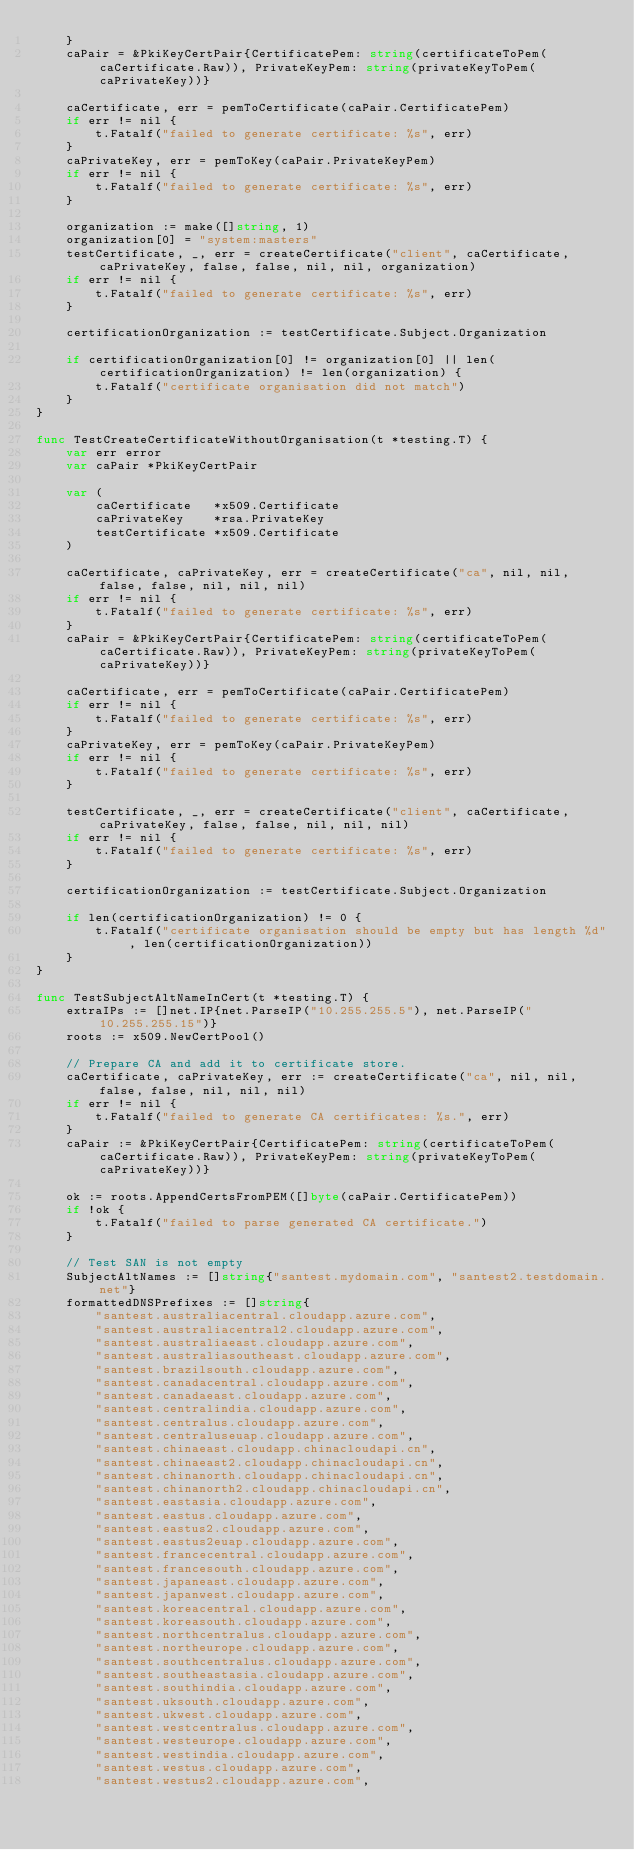Convert code to text. <code><loc_0><loc_0><loc_500><loc_500><_Go_>	}
	caPair = &PkiKeyCertPair{CertificatePem: string(certificateToPem(caCertificate.Raw)), PrivateKeyPem: string(privateKeyToPem(caPrivateKey))}

	caCertificate, err = pemToCertificate(caPair.CertificatePem)
	if err != nil {
		t.Fatalf("failed to generate certificate: %s", err)
	}
	caPrivateKey, err = pemToKey(caPair.PrivateKeyPem)
	if err != nil {
		t.Fatalf("failed to generate certificate: %s", err)
	}

	organization := make([]string, 1)
	organization[0] = "system:masters"
	testCertificate, _, err = createCertificate("client", caCertificate, caPrivateKey, false, false, nil, nil, organization)
	if err != nil {
		t.Fatalf("failed to generate certificate: %s", err)
	}

	certificationOrganization := testCertificate.Subject.Organization

	if certificationOrganization[0] != organization[0] || len(certificationOrganization) != len(organization) {
		t.Fatalf("certificate organisation did not match")
	}
}

func TestCreateCertificateWithoutOrganisation(t *testing.T) {
	var err error
	var caPair *PkiKeyCertPair

	var (
		caCertificate   *x509.Certificate
		caPrivateKey    *rsa.PrivateKey
		testCertificate *x509.Certificate
	)

	caCertificate, caPrivateKey, err = createCertificate("ca", nil, nil, false, false, nil, nil, nil)
	if err != nil {
		t.Fatalf("failed to generate certificate: %s", err)
	}
	caPair = &PkiKeyCertPair{CertificatePem: string(certificateToPem(caCertificate.Raw)), PrivateKeyPem: string(privateKeyToPem(caPrivateKey))}

	caCertificate, err = pemToCertificate(caPair.CertificatePem)
	if err != nil {
		t.Fatalf("failed to generate certificate: %s", err)
	}
	caPrivateKey, err = pemToKey(caPair.PrivateKeyPem)
	if err != nil {
		t.Fatalf("failed to generate certificate: %s", err)
	}

	testCertificate, _, err = createCertificate("client", caCertificate, caPrivateKey, false, false, nil, nil, nil)
	if err != nil {
		t.Fatalf("failed to generate certificate: %s", err)
	}

	certificationOrganization := testCertificate.Subject.Organization

	if len(certificationOrganization) != 0 {
		t.Fatalf("certificate organisation should be empty but has length %d", len(certificationOrganization))
	}
}

func TestSubjectAltNameInCert(t *testing.T) {
	extraIPs := []net.IP{net.ParseIP("10.255.255.5"), net.ParseIP("10.255.255.15")}
	roots := x509.NewCertPool()

	// Prepare CA and add it to certificate store.
	caCertificate, caPrivateKey, err := createCertificate("ca", nil, nil, false, false, nil, nil, nil)
	if err != nil {
		t.Fatalf("failed to generate CA certificates: %s.", err)
	}
	caPair := &PkiKeyCertPair{CertificatePem: string(certificateToPem(caCertificate.Raw)), PrivateKeyPem: string(privateKeyToPem(caPrivateKey))}

	ok := roots.AppendCertsFromPEM([]byte(caPair.CertificatePem))
	if !ok {
		t.Fatalf("failed to parse generated CA certificate.")
	}

	// Test SAN is not empty
	SubjectAltNames := []string{"santest.mydomain.com", "santest2.testdomain.net"}
	formattedDNSPrefixes := []string{
		"santest.australiacentral.cloudapp.azure.com",
		"santest.australiacentral2.cloudapp.azure.com",
		"santest.australiaeast.cloudapp.azure.com",
		"santest.australiasoutheast.cloudapp.azure.com",
		"santest.brazilsouth.cloudapp.azure.com",
		"santest.canadacentral.cloudapp.azure.com",
		"santest.canadaeast.cloudapp.azure.com",
		"santest.centralindia.cloudapp.azure.com",
		"santest.centralus.cloudapp.azure.com",
		"santest.centraluseuap.cloudapp.azure.com",
		"santest.chinaeast.cloudapp.chinacloudapi.cn",
		"santest.chinaeast2.cloudapp.chinacloudapi.cn",
		"santest.chinanorth.cloudapp.chinacloudapi.cn",
		"santest.chinanorth2.cloudapp.chinacloudapi.cn",
		"santest.eastasia.cloudapp.azure.com",
		"santest.eastus.cloudapp.azure.com",
		"santest.eastus2.cloudapp.azure.com",
		"santest.eastus2euap.cloudapp.azure.com",
		"santest.francecentral.cloudapp.azure.com",
		"santest.francesouth.cloudapp.azure.com",
		"santest.japaneast.cloudapp.azure.com",
		"santest.japanwest.cloudapp.azure.com",
		"santest.koreacentral.cloudapp.azure.com",
		"santest.koreasouth.cloudapp.azure.com",
		"santest.northcentralus.cloudapp.azure.com",
		"santest.northeurope.cloudapp.azure.com",
		"santest.southcentralus.cloudapp.azure.com",
		"santest.southeastasia.cloudapp.azure.com",
		"santest.southindia.cloudapp.azure.com",
		"santest.uksouth.cloudapp.azure.com",
		"santest.ukwest.cloudapp.azure.com",
		"santest.westcentralus.cloudapp.azure.com",
		"santest.westeurope.cloudapp.azure.com",
		"santest.westindia.cloudapp.azure.com",
		"santest.westus.cloudapp.azure.com",
		"santest.westus2.cloudapp.azure.com",</code> 